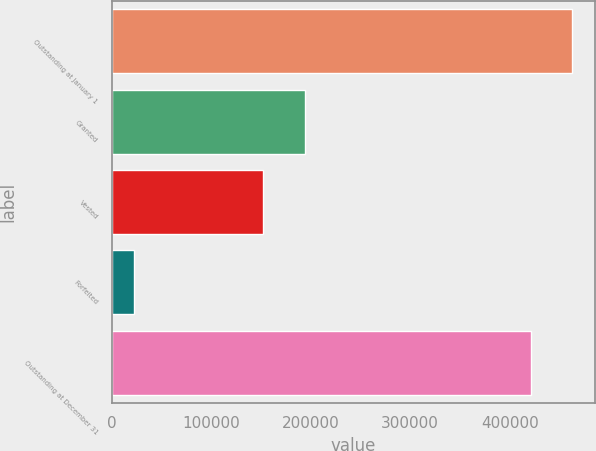Convert chart. <chart><loc_0><loc_0><loc_500><loc_500><bar_chart><fcel>Outstanding at January 1<fcel>Granted<fcel>Vested<fcel>Forfeited<fcel>Outstanding at December 31<nl><fcel>462608<fcel>193744<fcel>152397<fcel>21865<fcel>421261<nl></chart> 